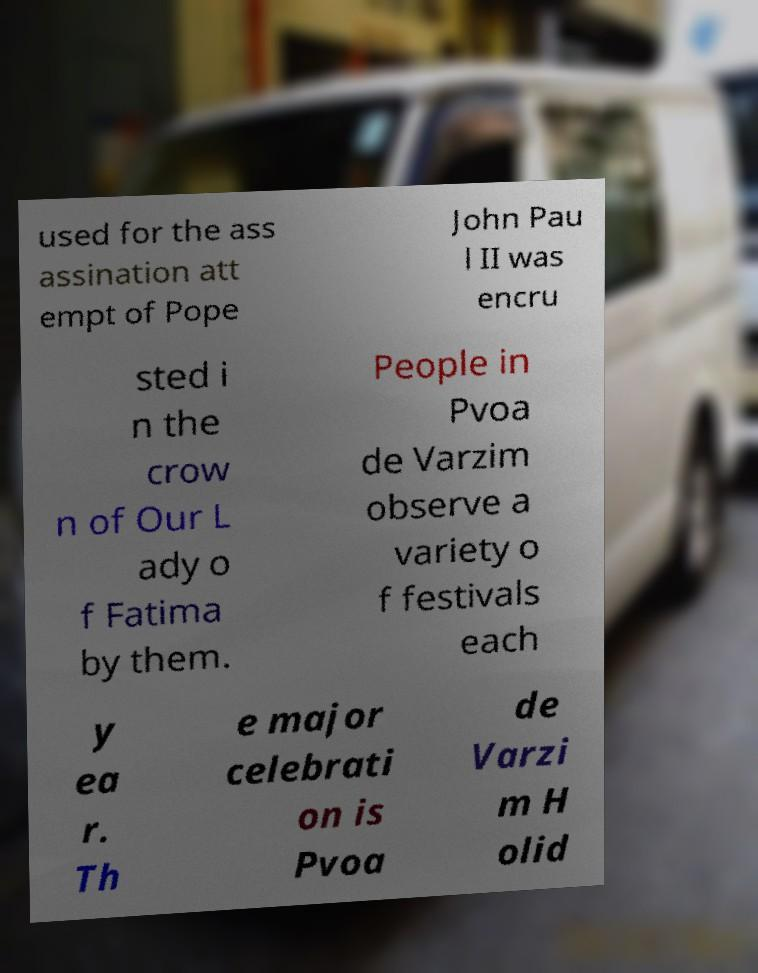Could you extract and type out the text from this image? used for the ass assination att empt of Pope John Pau l II was encru sted i n the crow n of Our L ady o f Fatima by them. People in Pvoa de Varzim observe a variety o f festivals each y ea r. Th e major celebrati on is Pvoa de Varzi m H olid 